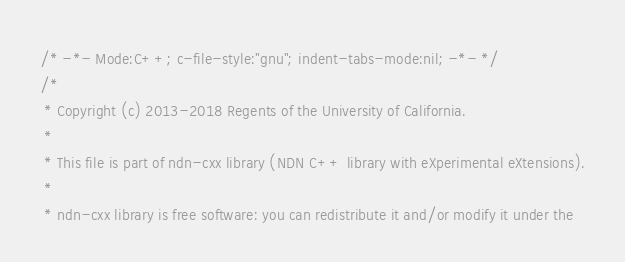<code> <loc_0><loc_0><loc_500><loc_500><_C++_>/* -*- Mode:C++; c-file-style:"gnu"; indent-tabs-mode:nil; -*- */
/*
 * Copyright (c) 2013-2018 Regents of the University of California.
 *
 * This file is part of ndn-cxx library (NDN C++ library with eXperimental eXtensions).
 *
 * ndn-cxx library is free software: you can redistribute it and/or modify it under the</code> 